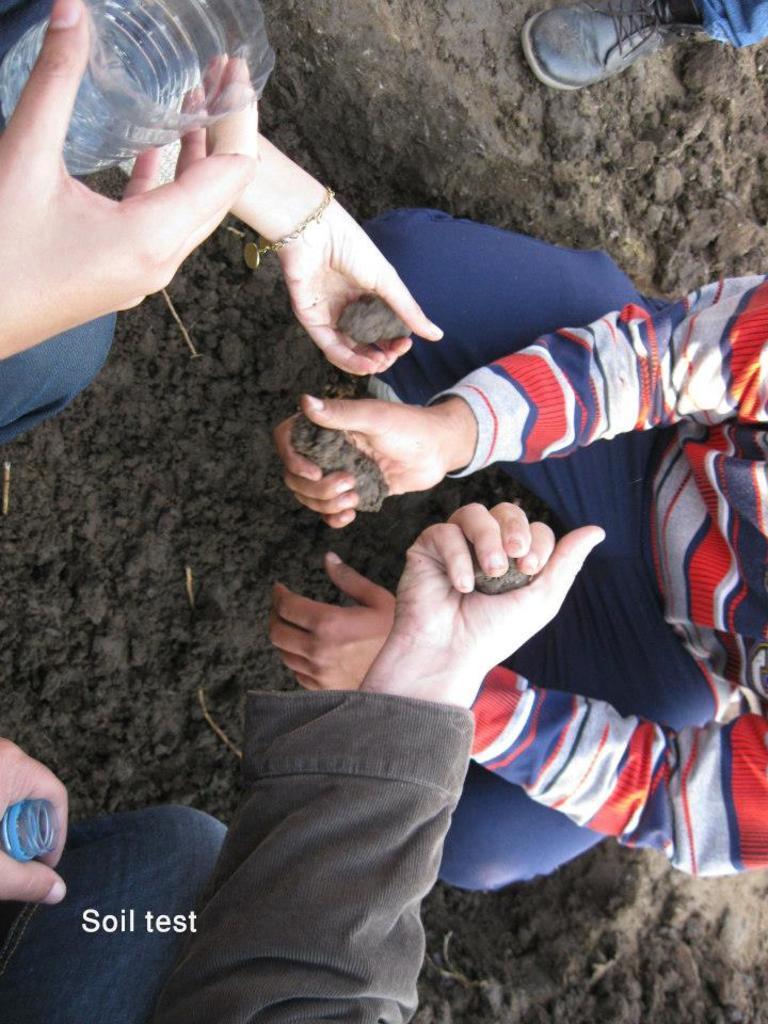Can you describe this image briefly? In this image I can see a picture of three people hands, holding soil. There are plastic water bottles and soil on the ground, also there is a shoe. 